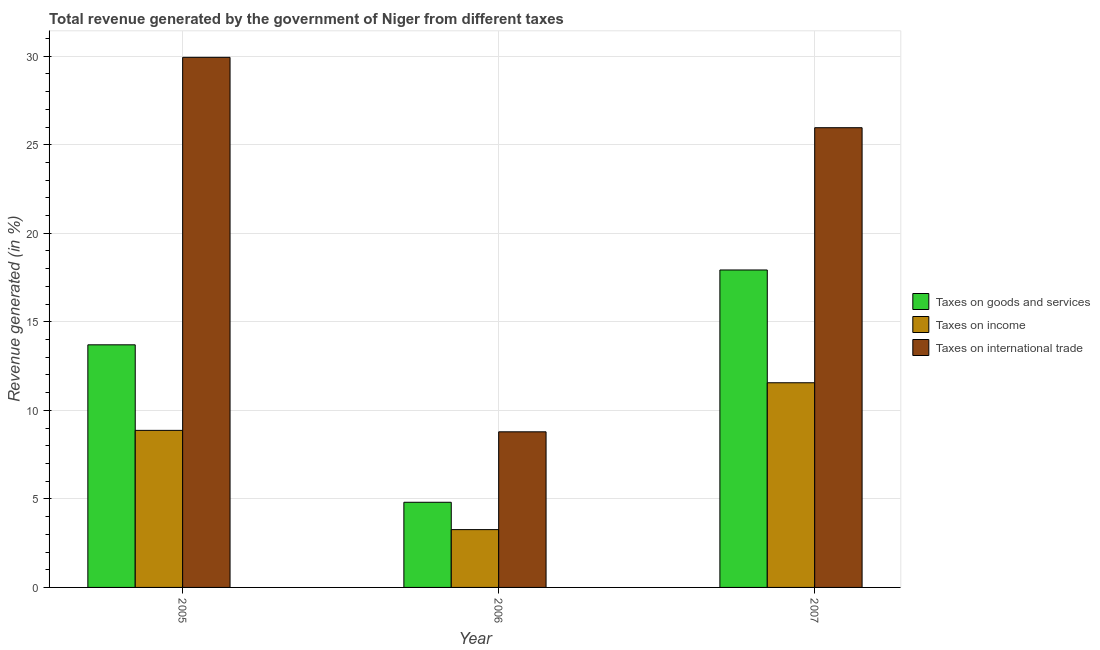How many different coloured bars are there?
Your response must be concise. 3. Are the number of bars per tick equal to the number of legend labels?
Ensure brevity in your answer.  Yes. Are the number of bars on each tick of the X-axis equal?
Make the answer very short. Yes. What is the label of the 2nd group of bars from the left?
Make the answer very short. 2006. In how many cases, is the number of bars for a given year not equal to the number of legend labels?
Ensure brevity in your answer.  0. What is the percentage of revenue generated by tax on international trade in 2007?
Your answer should be compact. 25.96. Across all years, what is the maximum percentage of revenue generated by tax on international trade?
Make the answer very short. 29.93. Across all years, what is the minimum percentage of revenue generated by taxes on income?
Ensure brevity in your answer.  3.26. In which year was the percentage of revenue generated by taxes on goods and services maximum?
Provide a short and direct response. 2007. In which year was the percentage of revenue generated by taxes on income minimum?
Offer a terse response. 2006. What is the total percentage of revenue generated by taxes on income in the graph?
Offer a terse response. 23.69. What is the difference between the percentage of revenue generated by taxes on income in 2005 and that in 2007?
Your response must be concise. -2.69. What is the difference between the percentage of revenue generated by tax on international trade in 2007 and the percentage of revenue generated by taxes on income in 2006?
Provide a short and direct response. 17.17. What is the average percentage of revenue generated by taxes on goods and services per year?
Provide a succinct answer. 12.15. What is the ratio of the percentage of revenue generated by taxes on income in 2005 to that in 2006?
Give a very brief answer. 2.72. What is the difference between the highest and the second highest percentage of revenue generated by taxes on goods and services?
Ensure brevity in your answer.  4.23. What is the difference between the highest and the lowest percentage of revenue generated by tax on international trade?
Your answer should be very brief. 21.15. Is the sum of the percentage of revenue generated by taxes on income in 2005 and 2007 greater than the maximum percentage of revenue generated by taxes on goods and services across all years?
Give a very brief answer. Yes. What does the 3rd bar from the left in 2005 represents?
Make the answer very short. Taxes on international trade. What does the 1st bar from the right in 2005 represents?
Your answer should be very brief. Taxes on international trade. Is it the case that in every year, the sum of the percentage of revenue generated by taxes on goods and services and percentage of revenue generated by taxes on income is greater than the percentage of revenue generated by tax on international trade?
Make the answer very short. No. How many bars are there?
Your response must be concise. 9. Are all the bars in the graph horizontal?
Offer a very short reply. No. Are the values on the major ticks of Y-axis written in scientific E-notation?
Your response must be concise. No. What is the title of the graph?
Give a very brief answer. Total revenue generated by the government of Niger from different taxes. What is the label or title of the X-axis?
Provide a succinct answer. Year. What is the label or title of the Y-axis?
Give a very brief answer. Revenue generated (in %). What is the Revenue generated (in %) in Taxes on goods and services in 2005?
Your response must be concise. 13.7. What is the Revenue generated (in %) in Taxes on income in 2005?
Offer a very short reply. 8.87. What is the Revenue generated (in %) in Taxes on international trade in 2005?
Your answer should be very brief. 29.93. What is the Revenue generated (in %) in Taxes on goods and services in 2006?
Make the answer very short. 4.81. What is the Revenue generated (in %) in Taxes on income in 2006?
Ensure brevity in your answer.  3.26. What is the Revenue generated (in %) of Taxes on international trade in 2006?
Make the answer very short. 8.79. What is the Revenue generated (in %) in Taxes on goods and services in 2007?
Your answer should be compact. 17.93. What is the Revenue generated (in %) in Taxes on income in 2007?
Make the answer very short. 11.56. What is the Revenue generated (in %) of Taxes on international trade in 2007?
Provide a short and direct response. 25.96. Across all years, what is the maximum Revenue generated (in %) of Taxes on goods and services?
Your answer should be compact. 17.93. Across all years, what is the maximum Revenue generated (in %) of Taxes on income?
Your answer should be very brief. 11.56. Across all years, what is the maximum Revenue generated (in %) in Taxes on international trade?
Give a very brief answer. 29.93. Across all years, what is the minimum Revenue generated (in %) of Taxes on goods and services?
Give a very brief answer. 4.81. Across all years, what is the minimum Revenue generated (in %) of Taxes on income?
Give a very brief answer. 3.26. Across all years, what is the minimum Revenue generated (in %) in Taxes on international trade?
Provide a succinct answer. 8.79. What is the total Revenue generated (in %) of Taxes on goods and services in the graph?
Ensure brevity in your answer.  36.44. What is the total Revenue generated (in %) in Taxes on income in the graph?
Give a very brief answer. 23.69. What is the total Revenue generated (in %) in Taxes on international trade in the graph?
Ensure brevity in your answer.  64.68. What is the difference between the Revenue generated (in %) of Taxes on goods and services in 2005 and that in 2006?
Keep it short and to the point. 8.89. What is the difference between the Revenue generated (in %) in Taxes on income in 2005 and that in 2006?
Ensure brevity in your answer.  5.61. What is the difference between the Revenue generated (in %) in Taxes on international trade in 2005 and that in 2006?
Make the answer very short. 21.15. What is the difference between the Revenue generated (in %) in Taxes on goods and services in 2005 and that in 2007?
Your response must be concise. -4.23. What is the difference between the Revenue generated (in %) in Taxes on income in 2005 and that in 2007?
Offer a very short reply. -2.69. What is the difference between the Revenue generated (in %) of Taxes on international trade in 2005 and that in 2007?
Provide a short and direct response. 3.97. What is the difference between the Revenue generated (in %) in Taxes on goods and services in 2006 and that in 2007?
Your response must be concise. -13.12. What is the difference between the Revenue generated (in %) of Taxes on income in 2006 and that in 2007?
Offer a terse response. -8.29. What is the difference between the Revenue generated (in %) in Taxes on international trade in 2006 and that in 2007?
Keep it short and to the point. -17.17. What is the difference between the Revenue generated (in %) of Taxes on goods and services in 2005 and the Revenue generated (in %) of Taxes on income in 2006?
Your response must be concise. 10.44. What is the difference between the Revenue generated (in %) of Taxes on goods and services in 2005 and the Revenue generated (in %) of Taxes on international trade in 2006?
Provide a short and direct response. 4.91. What is the difference between the Revenue generated (in %) in Taxes on income in 2005 and the Revenue generated (in %) in Taxes on international trade in 2006?
Provide a succinct answer. 0.08. What is the difference between the Revenue generated (in %) of Taxes on goods and services in 2005 and the Revenue generated (in %) of Taxes on income in 2007?
Make the answer very short. 2.14. What is the difference between the Revenue generated (in %) of Taxes on goods and services in 2005 and the Revenue generated (in %) of Taxes on international trade in 2007?
Your answer should be compact. -12.26. What is the difference between the Revenue generated (in %) in Taxes on income in 2005 and the Revenue generated (in %) in Taxes on international trade in 2007?
Provide a short and direct response. -17.09. What is the difference between the Revenue generated (in %) of Taxes on goods and services in 2006 and the Revenue generated (in %) of Taxes on income in 2007?
Your response must be concise. -6.75. What is the difference between the Revenue generated (in %) of Taxes on goods and services in 2006 and the Revenue generated (in %) of Taxes on international trade in 2007?
Your answer should be compact. -21.15. What is the difference between the Revenue generated (in %) of Taxes on income in 2006 and the Revenue generated (in %) of Taxes on international trade in 2007?
Make the answer very short. -22.7. What is the average Revenue generated (in %) of Taxes on goods and services per year?
Your answer should be very brief. 12.15. What is the average Revenue generated (in %) of Taxes on income per year?
Offer a terse response. 7.9. What is the average Revenue generated (in %) of Taxes on international trade per year?
Offer a very short reply. 21.56. In the year 2005, what is the difference between the Revenue generated (in %) of Taxes on goods and services and Revenue generated (in %) of Taxes on income?
Ensure brevity in your answer.  4.83. In the year 2005, what is the difference between the Revenue generated (in %) in Taxes on goods and services and Revenue generated (in %) in Taxes on international trade?
Provide a short and direct response. -16.23. In the year 2005, what is the difference between the Revenue generated (in %) of Taxes on income and Revenue generated (in %) of Taxes on international trade?
Your response must be concise. -21.07. In the year 2006, what is the difference between the Revenue generated (in %) of Taxes on goods and services and Revenue generated (in %) of Taxes on income?
Provide a succinct answer. 1.54. In the year 2006, what is the difference between the Revenue generated (in %) of Taxes on goods and services and Revenue generated (in %) of Taxes on international trade?
Provide a short and direct response. -3.98. In the year 2006, what is the difference between the Revenue generated (in %) of Taxes on income and Revenue generated (in %) of Taxes on international trade?
Provide a succinct answer. -5.52. In the year 2007, what is the difference between the Revenue generated (in %) of Taxes on goods and services and Revenue generated (in %) of Taxes on income?
Give a very brief answer. 6.37. In the year 2007, what is the difference between the Revenue generated (in %) in Taxes on goods and services and Revenue generated (in %) in Taxes on international trade?
Your answer should be very brief. -8.03. In the year 2007, what is the difference between the Revenue generated (in %) of Taxes on income and Revenue generated (in %) of Taxes on international trade?
Ensure brevity in your answer.  -14.4. What is the ratio of the Revenue generated (in %) of Taxes on goods and services in 2005 to that in 2006?
Keep it short and to the point. 2.85. What is the ratio of the Revenue generated (in %) of Taxes on income in 2005 to that in 2006?
Give a very brief answer. 2.72. What is the ratio of the Revenue generated (in %) of Taxes on international trade in 2005 to that in 2006?
Provide a succinct answer. 3.41. What is the ratio of the Revenue generated (in %) of Taxes on goods and services in 2005 to that in 2007?
Your answer should be compact. 0.76. What is the ratio of the Revenue generated (in %) in Taxes on income in 2005 to that in 2007?
Your answer should be very brief. 0.77. What is the ratio of the Revenue generated (in %) of Taxes on international trade in 2005 to that in 2007?
Give a very brief answer. 1.15. What is the ratio of the Revenue generated (in %) of Taxes on goods and services in 2006 to that in 2007?
Your answer should be compact. 0.27. What is the ratio of the Revenue generated (in %) in Taxes on income in 2006 to that in 2007?
Give a very brief answer. 0.28. What is the ratio of the Revenue generated (in %) of Taxes on international trade in 2006 to that in 2007?
Offer a terse response. 0.34. What is the difference between the highest and the second highest Revenue generated (in %) in Taxes on goods and services?
Provide a succinct answer. 4.23. What is the difference between the highest and the second highest Revenue generated (in %) of Taxes on income?
Provide a succinct answer. 2.69. What is the difference between the highest and the second highest Revenue generated (in %) of Taxes on international trade?
Make the answer very short. 3.97. What is the difference between the highest and the lowest Revenue generated (in %) of Taxes on goods and services?
Provide a short and direct response. 13.12. What is the difference between the highest and the lowest Revenue generated (in %) of Taxes on income?
Offer a very short reply. 8.29. What is the difference between the highest and the lowest Revenue generated (in %) of Taxes on international trade?
Keep it short and to the point. 21.15. 